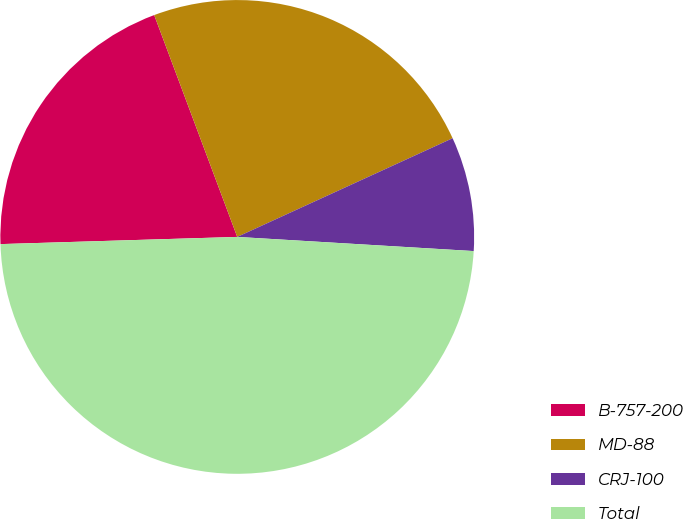Convert chart. <chart><loc_0><loc_0><loc_500><loc_500><pie_chart><fcel>B-757-200<fcel>MD-88<fcel>CRJ-100<fcel>Total<nl><fcel>19.78%<fcel>23.86%<fcel>7.79%<fcel>48.56%<nl></chart> 